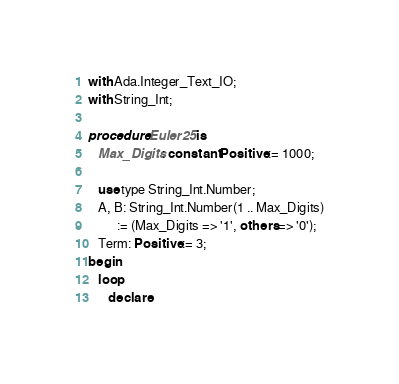Convert code to text. <code><loc_0><loc_0><loc_500><loc_500><_Ada_>with Ada.Integer_Text_IO;
with String_Int;

procedure Euler25 is
   Max_Digits: constant Positive := 1000;

   use type String_Int.Number;
   A, B: String_Int.Number(1 .. Max_Digits)
         := (Max_Digits => '1', others => '0');
   Term: Positive := 3;
begin
   loop
      declare</code> 